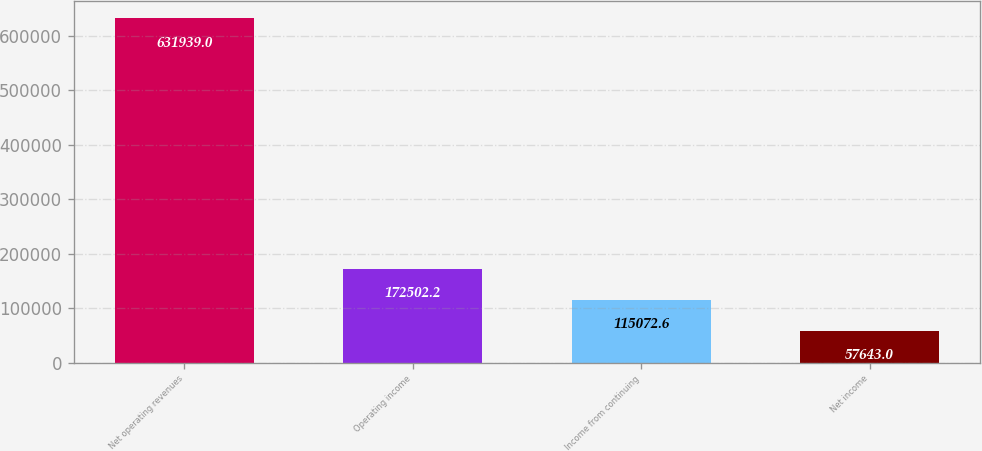<chart> <loc_0><loc_0><loc_500><loc_500><bar_chart><fcel>Net operating revenues<fcel>Operating income<fcel>Income from continuing<fcel>Net income<nl><fcel>631939<fcel>172502<fcel>115073<fcel>57643<nl></chart> 